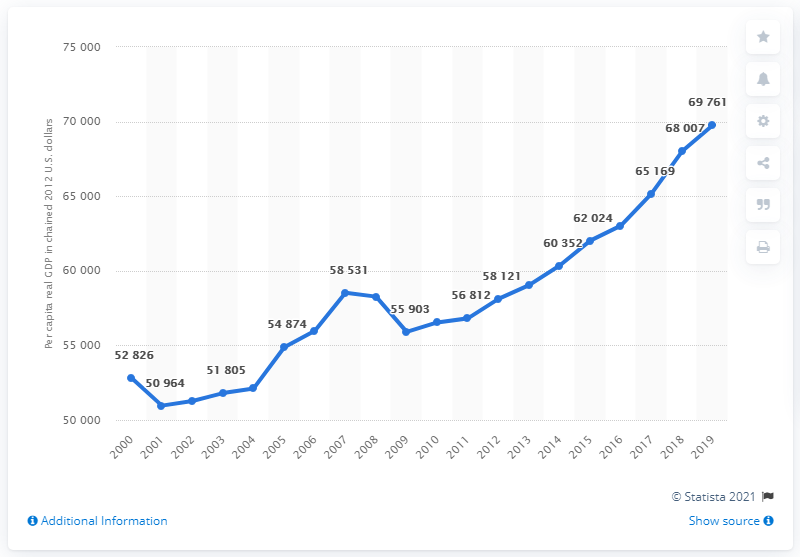Point out several critical features in this image. In the year 2012, the per capita real GDP of Washington stood at 69,761, adjusted for inflation and reflecting the changing value of goods and services produced. In 2018 and 2019, the total GDP was 137,768. As of 2001, the per capita real GDP was 50,964. 